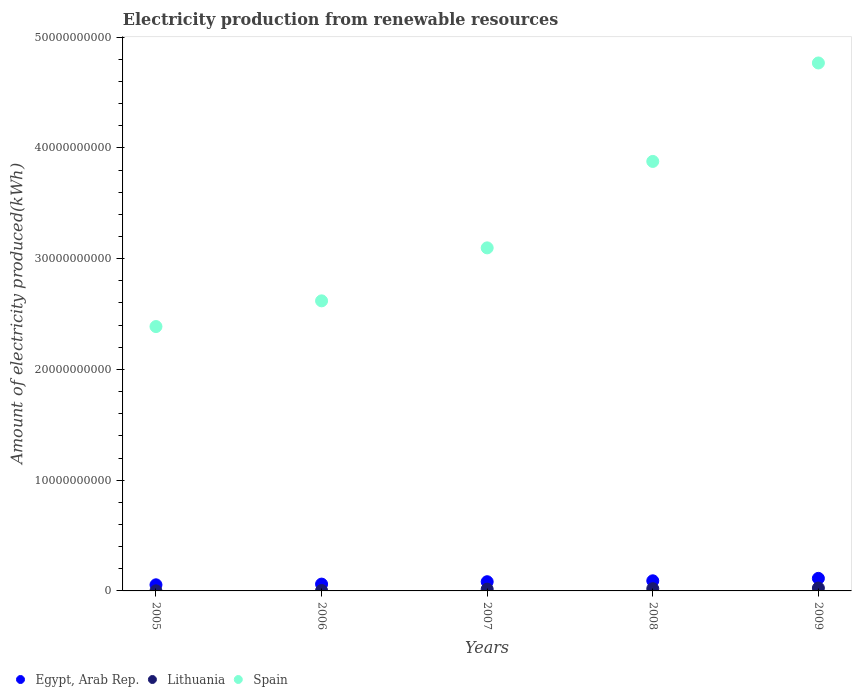How many different coloured dotlines are there?
Make the answer very short. 3. Is the number of dotlines equal to the number of legend labels?
Ensure brevity in your answer.  Yes. What is the amount of electricity produced in Spain in 2009?
Make the answer very short. 4.77e+1. Across all years, what is the maximum amount of electricity produced in Spain?
Provide a short and direct response. 4.77e+1. Across all years, what is the minimum amount of electricity produced in Egypt, Arab Rep.?
Offer a very short reply. 5.52e+08. In which year was the amount of electricity produced in Lithuania maximum?
Provide a succinct answer. 2009. In which year was the amount of electricity produced in Lithuania minimum?
Your answer should be compact. 2005. What is the total amount of electricity produced in Spain in the graph?
Offer a terse response. 1.67e+11. What is the difference between the amount of electricity produced in Egypt, Arab Rep. in 2006 and that in 2007?
Ensure brevity in your answer.  -2.15e+08. What is the difference between the amount of electricity produced in Egypt, Arab Rep. in 2006 and the amount of electricity produced in Lithuania in 2008?
Offer a very short reply. 4.16e+08. What is the average amount of electricity produced in Spain per year?
Offer a very short reply. 3.35e+1. In the year 2005, what is the difference between the amount of electricity produced in Lithuania and amount of electricity produced in Spain?
Offer a terse response. -2.39e+1. What is the ratio of the amount of electricity produced in Spain in 2007 to that in 2008?
Offer a terse response. 0.8. Is the amount of electricity produced in Lithuania in 2005 less than that in 2006?
Offer a terse response. Yes. What is the difference between the highest and the second highest amount of electricity produced in Spain?
Your response must be concise. 8.89e+09. What is the difference between the highest and the lowest amount of electricity produced in Egypt, Arab Rep.?
Your response must be concise. 5.81e+08. Does the amount of electricity produced in Spain monotonically increase over the years?
Ensure brevity in your answer.  Yes. Is the amount of electricity produced in Spain strictly greater than the amount of electricity produced in Egypt, Arab Rep. over the years?
Ensure brevity in your answer.  Yes. Is the amount of electricity produced in Spain strictly less than the amount of electricity produced in Egypt, Arab Rep. over the years?
Offer a terse response. No. Does the graph contain any zero values?
Your answer should be very brief. No. Does the graph contain grids?
Your response must be concise. No. How many legend labels are there?
Your answer should be compact. 3. What is the title of the graph?
Your answer should be very brief. Electricity production from renewable resources. What is the label or title of the X-axis?
Offer a very short reply. Years. What is the label or title of the Y-axis?
Ensure brevity in your answer.  Amount of electricity produced(kWh). What is the Amount of electricity produced(kWh) of Egypt, Arab Rep. in 2005?
Offer a terse response. 5.52e+08. What is the Amount of electricity produced(kWh) of Lithuania in 2005?
Your answer should be very brief. 9.00e+06. What is the Amount of electricity produced(kWh) in Spain in 2005?
Ensure brevity in your answer.  2.39e+1. What is the Amount of electricity produced(kWh) in Egypt, Arab Rep. in 2006?
Provide a succinct answer. 6.16e+08. What is the Amount of electricity produced(kWh) of Lithuania in 2006?
Your answer should be very brief. 3.80e+07. What is the Amount of electricity produced(kWh) of Spain in 2006?
Your response must be concise. 2.62e+1. What is the Amount of electricity produced(kWh) in Egypt, Arab Rep. in 2007?
Your response must be concise. 8.31e+08. What is the Amount of electricity produced(kWh) of Lithuania in 2007?
Provide a short and direct response. 1.60e+08. What is the Amount of electricity produced(kWh) in Spain in 2007?
Your answer should be compact. 3.10e+1. What is the Amount of electricity produced(kWh) in Egypt, Arab Rep. in 2008?
Provide a short and direct response. 9.13e+08. What is the Amount of electricity produced(kWh) of Lithuania in 2008?
Make the answer very short. 2.00e+08. What is the Amount of electricity produced(kWh) in Spain in 2008?
Offer a terse response. 3.88e+1. What is the Amount of electricity produced(kWh) in Egypt, Arab Rep. in 2009?
Provide a short and direct response. 1.13e+09. What is the Amount of electricity produced(kWh) in Lithuania in 2009?
Keep it short and to the point. 2.60e+08. What is the Amount of electricity produced(kWh) in Spain in 2009?
Give a very brief answer. 4.77e+1. Across all years, what is the maximum Amount of electricity produced(kWh) in Egypt, Arab Rep.?
Provide a short and direct response. 1.13e+09. Across all years, what is the maximum Amount of electricity produced(kWh) of Lithuania?
Your response must be concise. 2.60e+08. Across all years, what is the maximum Amount of electricity produced(kWh) of Spain?
Your answer should be compact. 4.77e+1. Across all years, what is the minimum Amount of electricity produced(kWh) in Egypt, Arab Rep.?
Ensure brevity in your answer.  5.52e+08. Across all years, what is the minimum Amount of electricity produced(kWh) of Lithuania?
Provide a succinct answer. 9.00e+06. Across all years, what is the minimum Amount of electricity produced(kWh) in Spain?
Make the answer very short. 2.39e+1. What is the total Amount of electricity produced(kWh) of Egypt, Arab Rep. in the graph?
Offer a very short reply. 4.04e+09. What is the total Amount of electricity produced(kWh) of Lithuania in the graph?
Make the answer very short. 6.67e+08. What is the total Amount of electricity produced(kWh) of Spain in the graph?
Ensure brevity in your answer.  1.67e+11. What is the difference between the Amount of electricity produced(kWh) of Egypt, Arab Rep. in 2005 and that in 2006?
Make the answer very short. -6.40e+07. What is the difference between the Amount of electricity produced(kWh) of Lithuania in 2005 and that in 2006?
Give a very brief answer. -2.90e+07. What is the difference between the Amount of electricity produced(kWh) in Spain in 2005 and that in 2006?
Provide a succinct answer. -2.32e+09. What is the difference between the Amount of electricity produced(kWh) in Egypt, Arab Rep. in 2005 and that in 2007?
Make the answer very short. -2.79e+08. What is the difference between the Amount of electricity produced(kWh) of Lithuania in 2005 and that in 2007?
Provide a succinct answer. -1.51e+08. What is the difference between the Amount of electricity produced(kWh) of Spain in 2005 and that in 2007?
Give a very brief answer. -7.10e+09. What is the difference between the Amount of electricity produced(kWh) of Egypt, Arab Rep. in 2005 and that in 2008?
Your answer should be compact. -3.61e+08. What is the difference between the Amount of electricity produced(kWh) of Lithuania in 2005 and that in 2008?
Offer a terse response. -1.91e+08. What is the difference between the Amount of electricity produced(kWh) in Spain in 2005 and that in 2008?
Keep it short and to the point. -1.49e+1. What is the difference between the Amount of electricity produced(kWh) in Egypt, Arab Rep. in 2005 and that in 2009?
Your response must be concise. -5.81e+08. What is the difference between the Amount of electricity produced(kWh) of Lithuania in 2005 and that in 2009?
Provide a succinct answer. -2.51e+08. What is the difference between the Amount of electricity produced(kWh) of Spain in 2005 and that in 2009?
Make the answer very short. -2.38e+1. What is the difference between the Amount of electricity produced(kWh) in Egypt, Arab Rep. in 2006 and that in 2007?
Provide a succinct answer. -2.15e+08. What is the difference between the Amount of electricity produced(kWh) in Lithuania in 2006 and that in 2007?
Your answer should be compact. -1.22e+08. What is the difference between the Amount of electricity produced(kWh) of Spain in 2006 and that in 2007?
Your response must be concise. -4.78e+09. What is the difference between the Amount of electricity produced(kWh) in Egypt, Arab Rep. in 2006 and that in 2008?
Your response must be concise. -2.97e+08. What is the difference between the Amount of electricity produced(kWh) of Lithuania in 2006 and that in 2008?
Your answer should be compact. -1.62e+08. What is the difference between the Amount of electricity produced(kWh) of Spain in 2006 and that in 2008?
Your response must be concise. -1.26e+1. What is the difference between the Amount of electricity produced(kWh) of Egypt, Arab Rep. in 2006 and that in 2009?
Offer a very short reply. -5.17e+08. What is the difference between the Amount of electricity produced(kWh) in Lithuania in 2006 and that in 2009?
Your answer should be compact. -2.22e+08. What is the difference between the Amount of electricity produced(kWh) in Spain in 2006 and that in 2009?
Make the answer very short. -2.15e+1. What is the difference between the Amount of electricity produced(kWh) of Egypt, Arab Rep. in 2007 and that in 2008?
Provide a succinct answer. -8.20e+07. What is the difference between the Amount of electricity produced(kWh) in Lithuania in 2007 and that in 2008?
Provide a succinct answer. -4.00e+07. What is the difference between the Amount of electricity produced(kWh) in Spain in 2007 and that in 2008?
Give a very brief answer. -7.80e+09. What is the difference between the Amount of electricity produced(kWh) in Egypt, Arab Rep. in 2007 and that in 2009?
Your response must be concise. -3.02e+08. What is the difference between the Amount of electricity produced(kWh) of Lithuania in 2007 and that in 2009?
Your answer should be compact. -1.00e+08. What is the difference between the Amount of electricity produced(kWh) in Spain in 2007 and that in 2009?
Ensure brevity in your answer.  -1.67e+1. What is the difference between the Amount of electricity produced(kWh) of Egypt, Arab Rep. in 2008 and that in 2009?
Give a very brief answer. -2.20e+08. What is the difference between the Amount of electricity produced(kWh) in Lithuania in 2008 and that in 2009?
Your response must be concise. -6.00e+07. What is the difference between the Amount of electricity produced(kWh) of Spain in 2008 and that in 2009?
Your response must be concise. -8.89e+09. What is the difference between the Amount of electricity produced(kWh) in Egypt, Arab Rep. in 2005 and the Amount of electricity produced(kWh) in Lithuania in 2006?
Ensure brevity in your answer.  5.14e+08. What is the difference between the Amount of electricity produced(kWh) of Egypt, Arab Rep. in 2005 and the Amount of electricity produced(kWh) of Spain in 2006?
Keep it short and to the point. -2.56e+1. What is the difference between the Amount of electricity produced(kWh) in Lithuania in 2005 and the Amount of electricity produced(kWh) in Spain in 2006?
Your answer should be compact. -2.62e+1. What is the difference between the Amount of electricity produced(kWh) in Egypt, Arab Rep. in 2005 and the Amount of electricity produced(kWh) in Lithuania in 2007?
Provide a succinct answer. 3.92e+08. What is the difference between the Amount of electricity produced(kWh) of Egypt, Arab Rep. in 2005 and the Amount of electricity produced(kWh) of Spain in 2007?
Your response must be concise. -3.04e+1. What is the difference between the Amount of electricity produced(kWh) in Lithuania in 2005 and the Amount of electricity produced(kWh) in Spain in 2007?
Your response must be concise. -3.10e+1. What is the difference between the Amount of electricity produced(kWh) in Egypt, Arab Rep. in 2005 and the Amount of electricity produced(kWh) in Lithuania in 2008?
Provide a succinct answer. 3.52e+08. What is the difference between the Amount of electricity produced(kWh) of Egypt, Arab Rep. in 2005 and the Amount of electricity produced(kWh) of Spain in 2008?
Offer a terse response. -3.82e+1. What is the difference between the Amount of electricity produced(kWh) of Lithuania in 2005 and the Amount of electricity produced(kWh) of Spain in 2008?
Provide a short and direct response. -3.88e+1. What is the difference between the Amount of electricity produced(kWh) in Egypt, Arab Rep. in 2005 and the Amount of electricity produced(kWh) in Lithuania in 2009?
Offer a very short reply. 2.92e+08. What is the difference between the Amount of electricity produced(kWh) in Egypt, Arab Rep. in 2005 and the Amount of electricity produced(kWh) in Spain in 2009?
Offer a terse response. -4.71e+1. What is the difference between the Amount of electricity produced(kWh) of Lithuania in 2005 and the Amount of electricity produced(kWh) of Spain in 2009?
Provide a succinct answer. -4.77e+1. What is the difference between the Amount of electricity produced(kWh) of Egypt, Arab Rep. in 2006 and the Amount of electricity produced(kWh) of Lithuania in 2007?
Keep it short and to the point. 4.56e+08. What is the difference between the Amount of electricity produced(kWh) of Egypt, Arab Rep. in 2006 and the Amount of electricity produced(kWh) of Spain in 2007?
Keep it short and to the point. -3.04e+1. What is the difference between the Amount of electricity produced(kWh) in Lithuania in 2006 and the Amount of electricity produced(kWh) in Spain in 2007?
Ensure brevity in your answer.  -3.09e+1. What is the difference between the Amount of electricity produced(kWh) of Egypt, Arab Rep. in 2006 and the Amount of electricity produced(kWh) of Lithuania in 2008?
Give a very brief answer. 4.16e+08. What is the difference between the Amount of electricity produced(kWh) in Egypt, Arab Rep. in 2006 and the Amount of electricity produced(kWh) in Spain in 2008?
Provide a short and direct response. -3.82e+1. What is the difference between the Amount of electricity produced(kWh) of Lithuania in 2006 and the Amount of electricity produced(kWh) of Spain in 2008?
Your response must be concise. -3.87e+1. What is the difference between the Amount of electricity produced(kWh) in Egypt, Arab Rep. in 2006 and the Amount of electricity produced(kWh) in Lithuania in 2009?
Your response must be concise. 3.56e+08. What is the difference between the Amount of electricity produced(kWh) of Egypt, Arab Rep. in 2006 and the Amount of electricity produced(kWh) of Spain in 2009?
Offer a very short reply. -4.71e+1. What is the difference between the Amount of electricity produced(kWh) in Lithuania in 2006 and the Amount of electricity produced(kWh) in Spain in 2009?
Give a very brief answer. -4.76e+1. What is the difference between the Amount of electricity produced(kWh) in Egypt, Arab Rep. in 2007 and the Amount of electricity produced(kWh) in Lithuania in 2008?
Your answer should be very brief. 6.31e+08. What is the difference between the Amount of electricity produced(kWh) of Egypt, Arab Rep. in 2007 and the Amount of electricity produced(kWh) of Spain in 2008?
Provide a succinct answer. -3.79e+1. What is the difference between the Amount of electricity produced(kWh) of Lithuania in 2007 and the Amount of electricity produced(kWh) of Spain in 2008?
Give a very brief answer. -3.86e+1. What is the difference between the Amount of electricity produced(kWh) of Egypt, Arab Rep. in 2007 and the Amount of electricity produced(kWh) of Lithuania in 2009?
Provide a succinct answer. 5.71e+08. What is the difference between the Amount of electricity produced(kWh) of Egypt, Arab Rep. in 2007 and the Amount of electricity produced(kWh) of Spain in 2009?
Your answer should be compact. -4.68e+1. What is the difference between the Amount of electricity produced(kWh) in Lithuania in 2007 and the Amount of electricity produced(kWh) in Spain in 2009?
Your response must be concise. -4.75e+1. What is the difference between the Amount of electricity produced(kWh) in Egypt, Arab Rep. in 2008 and the Amount of electricity produced(kWh) in Lithuania in 2009?
Provide a succinct answer. 6.53e+08. What is the difference between the Amount of electricity produced(kWh) of Egypt, Arab Rep. in 2008 and the Amount of electricity produced(kWh) of Spain in 2009?
Offer a very short reply. -4.68e+1. What is the difference between the Amount of electricity produced(kWh) in Lithuania in 2008 and the Amount of electricity produced(kWh) in Spain in 2009?
Keep it short and to the point. -4.75e+1. What is the average Amount of electricity produced(kWh) of Egypt, Arab Rep. per year?
Your response must be concise. 8.09e+08. What is the average Amount of electricity produced(kWh) in Lithuania per year?
Offer a terse response. 1.33e+08. What is the average Amount of electricity produced(kWh) of Spain per year?
Your answer should be very brief. 3.35e+1. In the year 2005, what is the difference between the Amount of electricity produced(kWh) of Egypt, Arab Rep. and Amount of electricity produced(kWh) of Lithuania?
Offer a terse response. 5.43e+08. In the year 2005, what is the difference between the Amount of electricity produced(kWh) of Egypt, Arab Rep. and Amount of electricity produced(kWh) of Spain?
Provide a short and direct response. -2.33e+1. In the year 2005, what is the difference between the Amount of electricity produced(kWh) in Lithuania and Amount of electricity produced(kWh) in Spain?
Offer a very short reply. -2.39e+1. In the year 2006, what is the difference between the Amount of electricity produced(kWh) in Egypt, Arab Rep. and Amount of electricity produced(kWh) in Lithuania?
Your answer should be very brief. 5.78e+08. In the year 2006, what is the difference between the Amount of electricity produced(kWh) in Egypt, Arab Rep. and Amount of electricity produced(kWh) in Spain?
Your answer should be very brief. -2.56e+1. In the year 2006, what is the difference between the Amount of electricity produced(kWh) in Lithuania and Amount of electricity produced(kWh) in Spain?
Your answer should be very brief. -2.62e+1. In the year 2007, what is the difference between the Amount of electricity produced(kWh) of Egypt, Arab Rep. and Amount of electricity produced(kWh) of Lithuania?
Offer a terse response. 6.71e+08. In the year 2007, what is the difference between the Amount of electricity produced(kWh) in Egypt, Arab Rep. and Amount of electricity produced(kWh) in Spain?
Provide a short and direct response. -3.01e+1. In the year 2007, what is the difference between the Amount of electricity produced(kWh) of Lithuania and Amount of electricity produced(kWh) of Spain?
Your answer should be compact. -3.08e+1. In the year 2008, what is the difference between the Amount of electricity produced(kWh) of Egypt, Arab Rep. and Amount of electricity produced(kWh) of Lithuania?
Keep it short and to the point. 7.13e+08. In the year 2008, what is the difference between the Amount of electricity produced(kWh) in Egypt, Arab Rep. and Amount of electricity produced(kWh) in Spain?
Offer a terse response. -3.79e+1. In the year 2008, what is the difference between the Amount of electricity produced(kWh) in Lithuania and Amount of electricity produced(kWh) in Spain?
Offer a terse response. -3.86e+1. In the year 2009, what is the difference between the Amount of electricity produced(kWh) in Egypt, Arab Rep. and Amount of electricity produced(kWh) in Lithuania?
Ensure brevity in your answer.  8.73e+08. In the year 2009, what is the difference between the Amount of electricity produced(kWh) of Egypt, Arab Rep. and Amount of electricity produced(kWh) of Spain?
Provide a short and direct response. -4.65e+1. In the year 2009, what is the difference between the Amount of electricity produced(kWh) in Lithuania and Amount of electricity produced(kWh) in Spain?
Make the answer very short. -4.74e+1. What is the ratio of the Amount of electricity produced(kWh) of Egypt, Arab Rep. in 2005 to that in 2006?
Your answer should be compact. 0.9. What is the ratio of the Amount of electricity produced(kWh) in Lithuania in 2005 to that in 2006?
Keep it short and to the point. 0.24. What is the ratio of the Amount of electricity produced(kWh) in Spain in 2005 to that in 2006?
Keep it short and to the point. 0.91. What is the ratio of the Amount of electricity produced(kWh) in Egypt, Arab Rep. in 2005 to that in 2007?
Your response must be concise. 0.66. What is the ratio of the Amount of electricity produced(kWh) of Lithuania in 2005 to that in 2007?
Keep it short and to the point. 0.06. What is the ratio of the Amount of electricity produced(kWh) of Spain in 2005 to that in 2007?
Offer a terse response. 0.77. What is the ratio of the Amount of electricity produced(kWh) in Egypt, Arab Rep. in 2005 to that in 2008?
Your response must be concise. 0.6. What is the ratio of the Amount of electricity produced(kWh) of Lithuania in 2005 to that in 2008?
Offer a terse response. 0.04. What is the ratio of the Amount of electricity produced(kWh) of Spain in 2005 to that in 2008?
Provide a succinct answer. 0.62. What is the ratio of the Amount of electricity produced(kWh) in Egypt, Arab Rep. in 2005 to that in 2009?
Your answer should be very brief. 0.49. What is the ratio of the Amount of electricity produced(kWh) in Lithuania in 2005 to that in 2009?
Make the answer very short. 0.03. What is the ratio of the Amount of electricity produced(kWh) in Spain in 2005 to that in 2009?
Keep it short and to the point. 0.5. What is the ratio of the Amount of electricity produced(kWh) in Egypt, Arab Rep. in 2006 to that in 2007?
Offer a very short reply. 0.74. What is the ratio of the Amount of electricity produced(kWh) of Lithuania in 2006 to that in 2007?
Your response must be concise. 0.24. What is the ratio of the Amount of electricity produced(kWh) of Spain in 2006 to that in 2007?
Keep it short and to the point. 0.85. What is the ratio of the Amount of electricity produced(kWh) of Egypt, Arab Rep. in 2006 to that in 2008?
Provide a short and direct response. 0.67. What is the ratio of the Amount of electricity produced(kWh) in Lithuania in 2006 to that in 2008?
Offer a terse response. 0.19. What is the ratio of the Amount of electricity produced(kWh) of Spain in 2006 to that in 2008?
Your response must be concise. 0.68. What is the ratio of the Amount of electricity produced(kWh) of Egypt, Arab Rep. in 2006 to that in 2009?
Your answer should be compact. 0.54. What is the ratio of the Amount of electricity produced(kWh) in Lithuania in 2006 to that in 2009?
Make the answer very short. 0.15. What is the ratio of the Amount of electricity produced(kWh) in Spain in 2006 to that in 2009?
Offer a very short reply. 0.55. What is the ratio of the Amount of electricity produced(kWh) of Egypt, Arab Rep. in 2007 to that in 2008?
Provide a short and direct response. 0.91. What is the ratio of the Amount of electricity produced(kWh) in Lithuania in 2007 to that in 2008?
Provide a short and direct response. 0.8. What is the ratio of the Amount of electricity produced(kWh) of Spain in 2007 to that in 2008?
Keep it short and to the point. 0.8. What is the ratio of the Amount of electricity produced(kWh) in Egypt, Arab Rep. in 2007 to that in 2009?
Make the answer very short. 0.73. What is the ratio of the Amount of electricity produced(kWh) in Lithuania in 2007 to that in 2009?
Keep it short and to the point. 0.62. What is the ratio of the Amount of electricity produced(kWh) in Spain in 2007 to that in 2009?
Give a very brief answer. 0.65. What is the ratio of the Amount of electricity produced(kWh) of Egypt, Arab Rep. in 2008 to that in 2009?
Offer a very short reply. 0.81. What is the ratio of the Amount of electricity produced(kWh) of Lithuania in 2008 to that in 2009?
Provide a short and direct response. 0.77. What is the ratio of the Amount of electricity produced(kWh) in Spain in 2008 to that in 2009?
Make the answer very short. 0.81. What is the difference between the highest and the second highest Amount of electricity produced(kWh) of Egypt, Arab Rep.?
Your answer should be compact. 2.20e+08. What is the difference between the highest and the second highest Amount of electricity produced(kWh) in Lithuania?
Make the answer very short. 6.00e+07. What is the difference between the highest and the second highest Amount of electricity produced(kWh) of Spain?
Make the answer very short. 8.89e+09. What is the difference between the highest and the lowest Amount of electricity produced(kWh) in Egypt, Arab Rep.?
Provide a succinct answer. 5.81e+08. What is the difference between the highest and the lowest Amount of electricity produced(kWh) of Lithuania?
Provide a short and direct response. 2.51e+08. What is the difference between the highest and the lowest Amount of electricity produced(kWh) in Spain?
Give a very brief answer. 2.38e+1. 